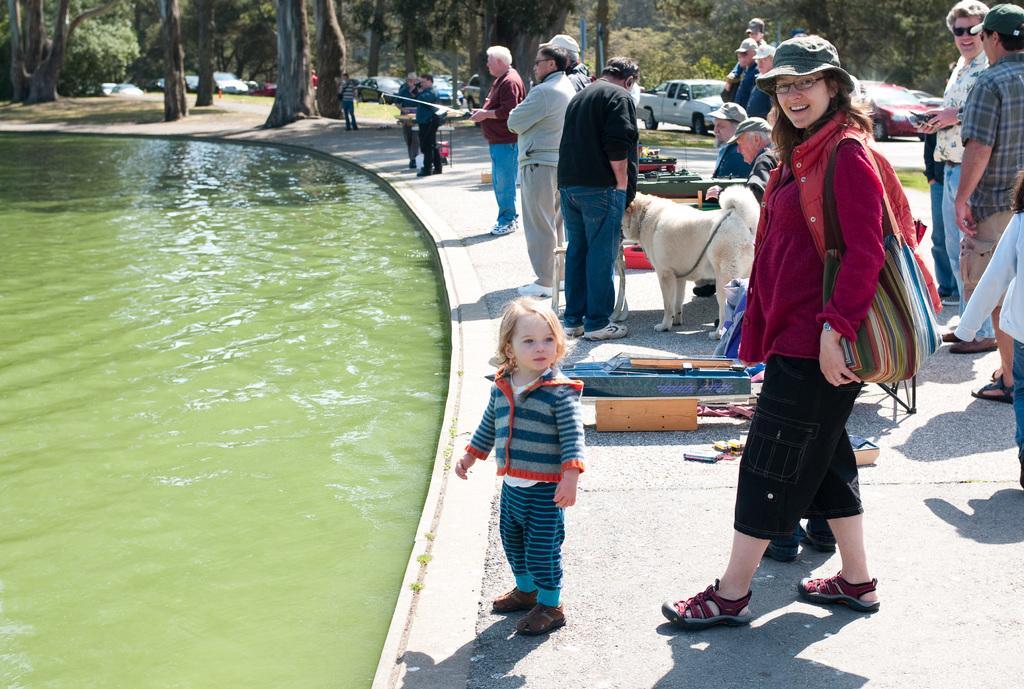Describe this image in one or two sentences. In this image I can see the water, the ground, few persons standing on the ground, a dog which is white in color, few other objects on the ground and in the background I can see few trees, the road and few vehicles on the road. 